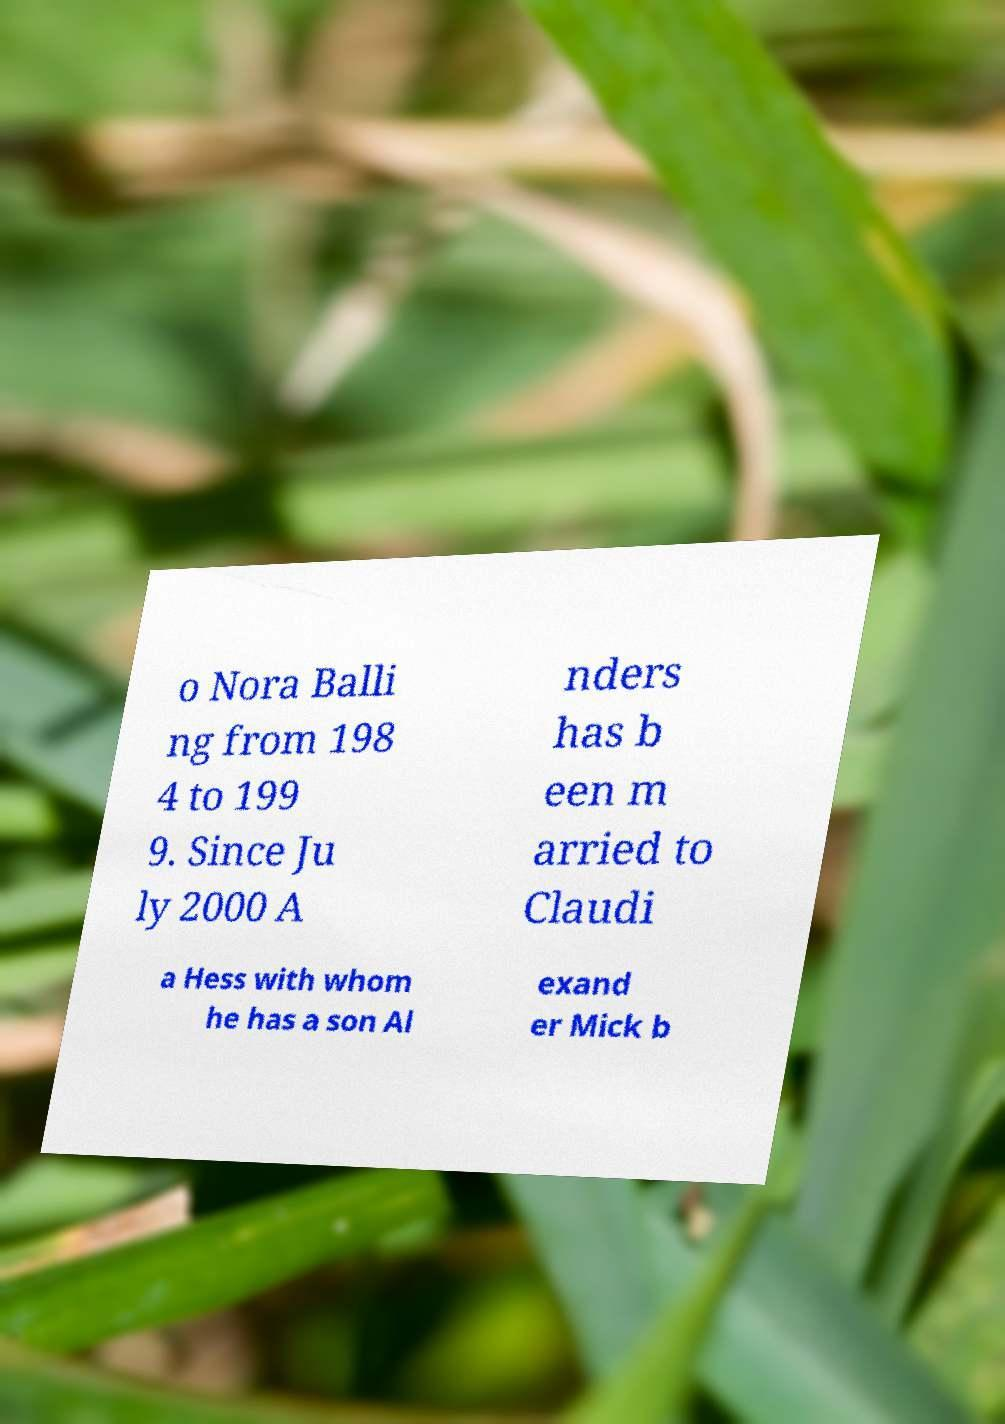Could you extract and type out the text from this image? o Nora Balli ng from 198 4 to 199 9. Since Ju ly 2000 A nders has b een m arried to Claudi a Hess with whom he has a son Al exand er Mick b 